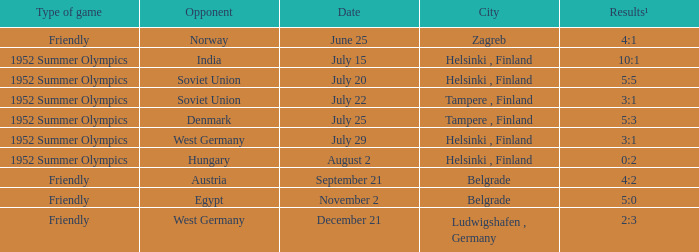What Type of game was played on Date of July 29? 1952 Summer Olympics. 